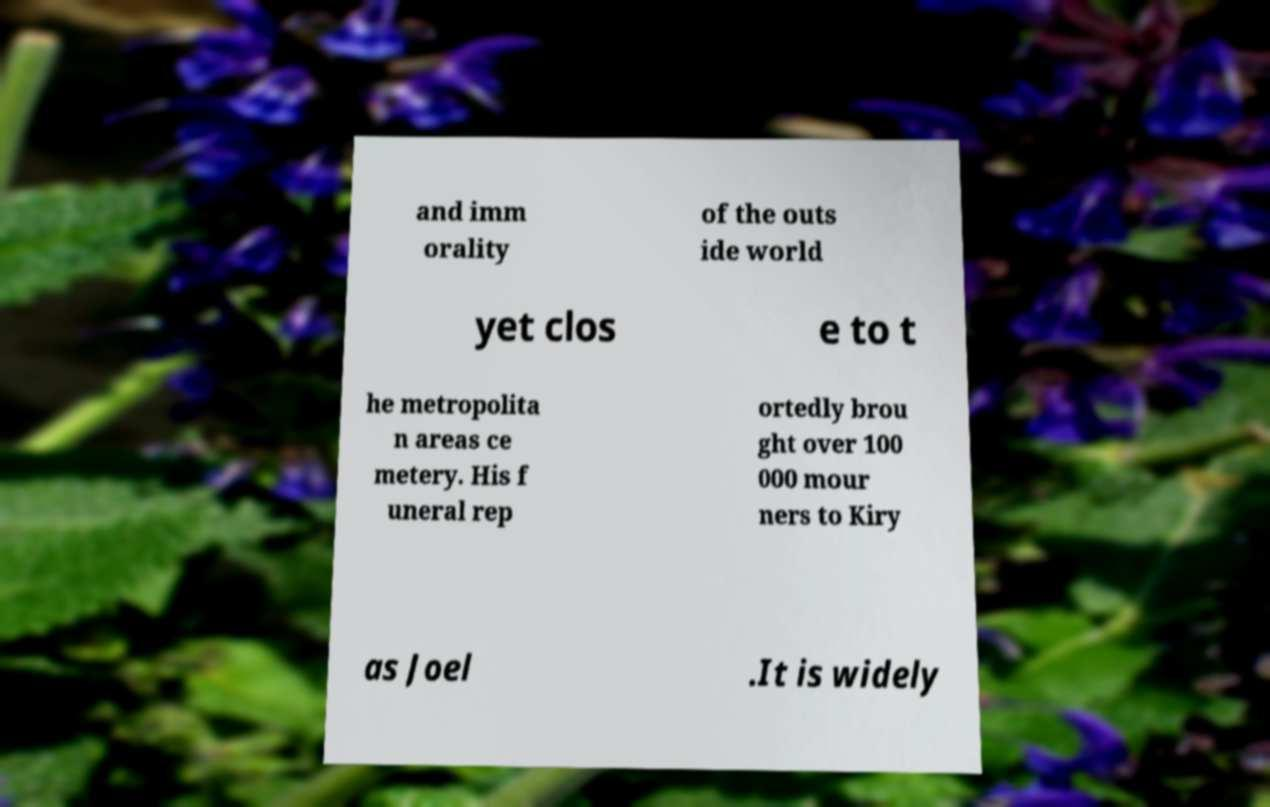I need the written content from this picture converted into text. Can you do that? and imm orality of the outs ide world yet clos e to t he metropolita n areas ce metery. His f uneral rep ortedly brou ght over 100 000 mour ners to Kiry as Joel .It is widely 